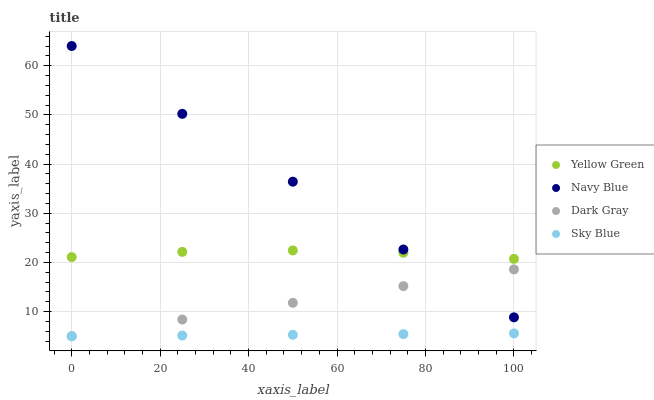Does Sky Blue have the minimum area under the curve?
Answer yes or no. Yes. Does Navy Blue have the maximum area under the curve?
Answer yes or no. Yes. Does Yellow Green have the minimum area under the curve?
Answer yes or no. No. Does Yellow Green have the maximum area under the curve?
Answer yes or no. No. Is Navy Blue the smoothest?
Answer yes or no. Yes. Is Yellow Green the roughest?
Answer yes or no. Yes. Is Yellow Green the smoothest?
Answer yes or no. No. Is Navy Blue the roughest?
Answer yes or no. No. Does Dark Gray have the lowest value?
Answer yes or no. Yes. Does Navy Blue have the lowest value?
Answer yes or no. No. Does Navy Blue have the highest value?
Answer yes or no. Yes. Does Yellow Green have the highest value?
Answer yes or no. No. Is Sky Blue less than Navy Blue?
Answer yes or no. Yes. Is Navy Blue greater than Sky Blue?
Answer yes or no. Yes. Does Navy Blue intersect Dark Gray?
Answer yes or no. Yes. Is Navy Blue less than Dark Gray?
Answer yes or no. No. Is Navy Blue greater than Dark Gray?
Answer yes or no. No. Does Sky Blue intersect Navy Blue?
Answer yes or no. No. 